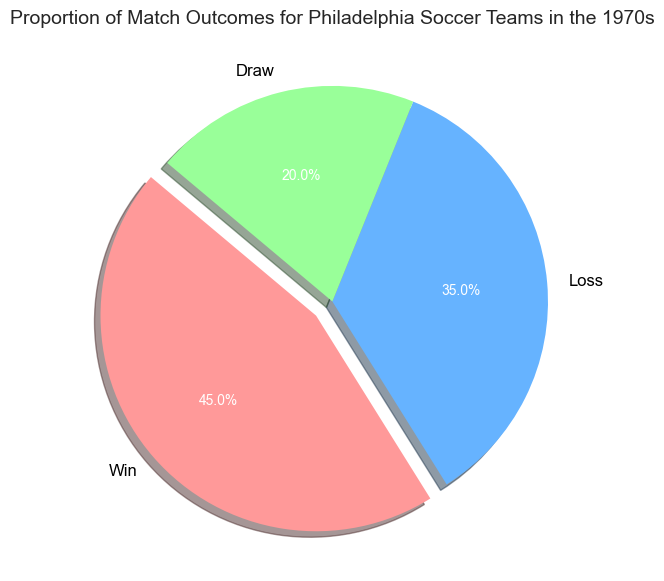What is the most common match outcome for Philadelphia soccer teams in the 1970s? The pie chart shows three categories: Win, Loss, and Draw, with Win having the largest slice at 45%. Therefore, the most common match outcome was Win
Answer: Win Which outcome has the smallest proportion in the chart? By looking at the pie chart, the Draw category occupies the smallest portion of the chart at 20%
Answer: Draw By how much did the proportion of Wins exceed the proportion of Draws? The Win proportion is 45%, and the Draw proportion is 20%. Subtracting the Draw proportion from the Win proportion: 45% - 20% = 25%
Answer: 25% Which two outcomes combined make up more than half of the total matches? The Win proportion is 45% and the Loss proportion is 35%. Adding these two gives us 45% + 35% = 80%, which is more than half of the matches
Answer: Win and Loss If the total number of matches played was 200, how many matches ended in a draw? 20% of the matches ended in a draw. To find the number of draws, calculate 20% of 200: (20/100) * 200 = 40
Answer: 40 What is the ratio of Wins to Losses? Look at the pie chart: Wins are 45% and Losses are 35%. The ratio of Wins to Losses is 45:35 which simplifies to 9:7
Answer: 9:7 Does the proportion of Wins exceed the combined proportion of Losses and Draws? Combined losses and draws are 35% + 20% = 55%, which is greater than 45% for Wins. So, the proportion of Wins does not exceed the combined proportion of Losses and Draws
Answer: No Which outcome has a larger proportion, Loss or Draw, and by how much? From the chart, Loss is 35% and Draw is 20%. The difference between these two proportions is 35% - 20% = 15%
Answer: Loss by 15% What proportion of the outcomes were not Wins? The chart shows Wins at 45%, so the proportion of outcomes that were not Wins is 100% - 45% = 55%
Answer: 55% 